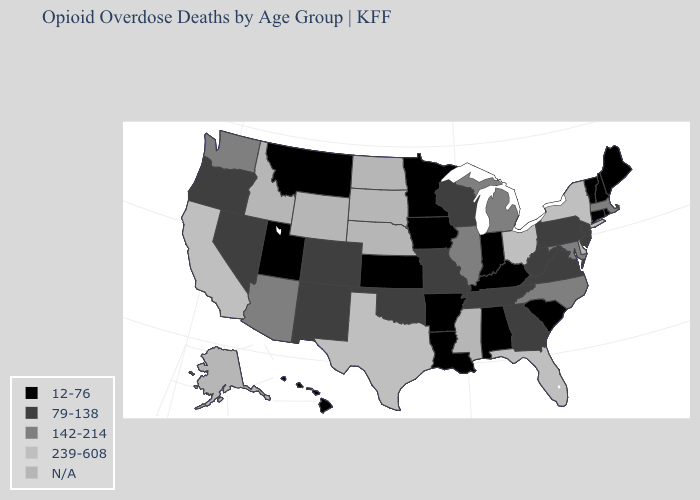What is the value of South Carolina?
Be succinct. 12-76. Name the states that have a value in the range 142-214?
Keep it brief. Arizona, Illinois, Maryland, Massachusetts, Michigan, North Carolina, Washington. Name the states that have a value in the range 12-76?
Short answer required. Alabama, Arkansas, Connecticut, Hawaii, Indiana, Iowa, Kansas, Kentucky, Louisiana, Maine, Minnesota, Montana, New Hampshire, Rhode Island, South Carolina, Utah, Vermont. Does the map have missing data?
Concise answer only. Yes. Does the map have missing data?
Concise answer only. Yes. What is the value of Michigan?
Quick response, please. 142-214. Is the legend a continuous bar?
Write a very short answer. No. Name the states that have a value in the range 142-214?
Answer briefly. Arizona, Illinois, Maryland, Massachusetts, Michigan, North Carolina, Washington. Among the states that border Texas , does Louisiana have the lowest value?
Write a very short answer. Yes. Name the states that have a value in the range 12-76?
Concise answer only. Alabama, Arkansas, Connecticut, Hawaii, Indiana, Iowa, Kansas, Kentucky, Louisiana, Maine, Minnesota, Montana, New Hampshire, Rhode Island, South Carolina, Utah, Vermont. Name the states that have a value in the range 142-214?
Answer briefly. Arizona, Illinois, Maryland, Massachusetts, Michigan, North Carolina, Washington. Does Ohio have the highest value in the MidWest?
Quick response, please. Yes. What is the value of New Mexico?
Give a very brief answer. 79-138. Name the states that have a value in the range 239-608?
Give a very brief answer. California, Florida, New York, Ohio, Texas. Does the map have missing data?
Quick response, please. Yes. 